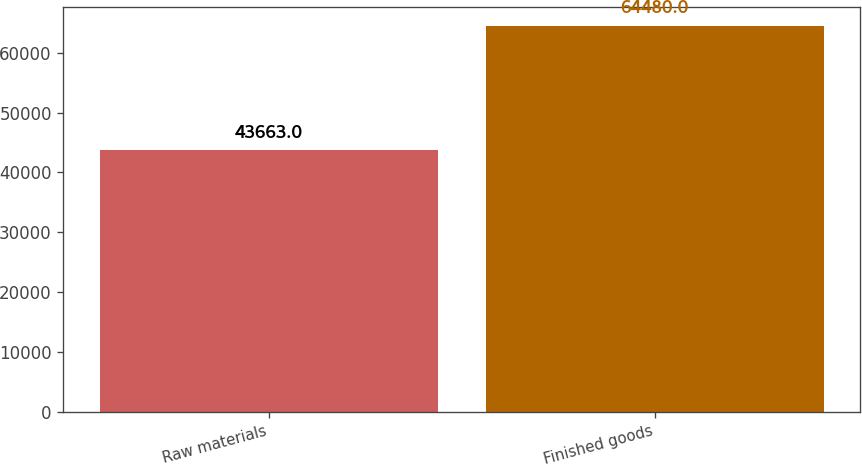Convert chart. <chart><loc_0><loc_0><loc_500><loc_500><bar_chart><fcel>Raw materials<fcel>Finished goods<nl><fcel>43663<fcel>64480<nl></chart> 